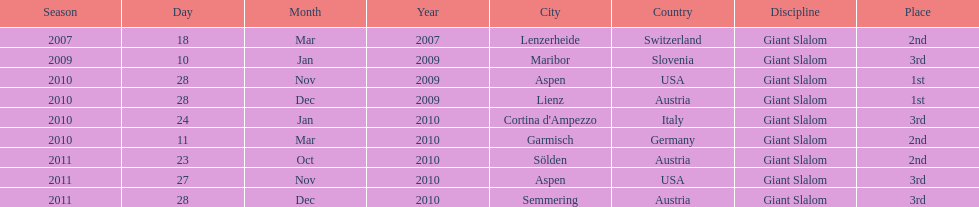Could you parse the entire table as a dict? {'header': ['Season', 'Day', 'Month', 'Year', 'City', 'Country', 'Discipline', 'Place'], 'rows': [['2007', '18', 'Mar', '2007', 'Lenzerheide', 'Switzerland', 'Giant Slalom', '2nd'], ['2009', '10', 'Jan', '2009', 'Maribor', 'Slovenia', 'Giant Slalom', '3rd'], ['2010', '28', 'Nov', '2009', 'Aspen', 'USA', 'Giant Slalom', '1st'], ['2010', '28', 'Dec', '2009', 'Lienz', 'Austria', 'Giant Slalom', '1st'], ['2010', '24', 'Jan', '2010', "Cortina d'Ampezzo", 'Italy', 'Giant Slalom', '3rd'], ['2010', '11', 'Mar', '2010', 'Garmisch', 'Germany', 'Giant Slalom', '2nd'], ['2011', '23', 'Oct', '2010', 'Sölden', 'Austria', 'Giant Slalom', '2nd'], ['2011', '27', 'Nov', '2010', 'Aspen', 'USA', 'Giant Slalom', '3rd'], ['2011', '28', 'Dec', '2010', 'Semmering', 'Austria', 'Giant Slalom', '3rd']]} What was the finishing place of the last race in december 2010? 3rd. 